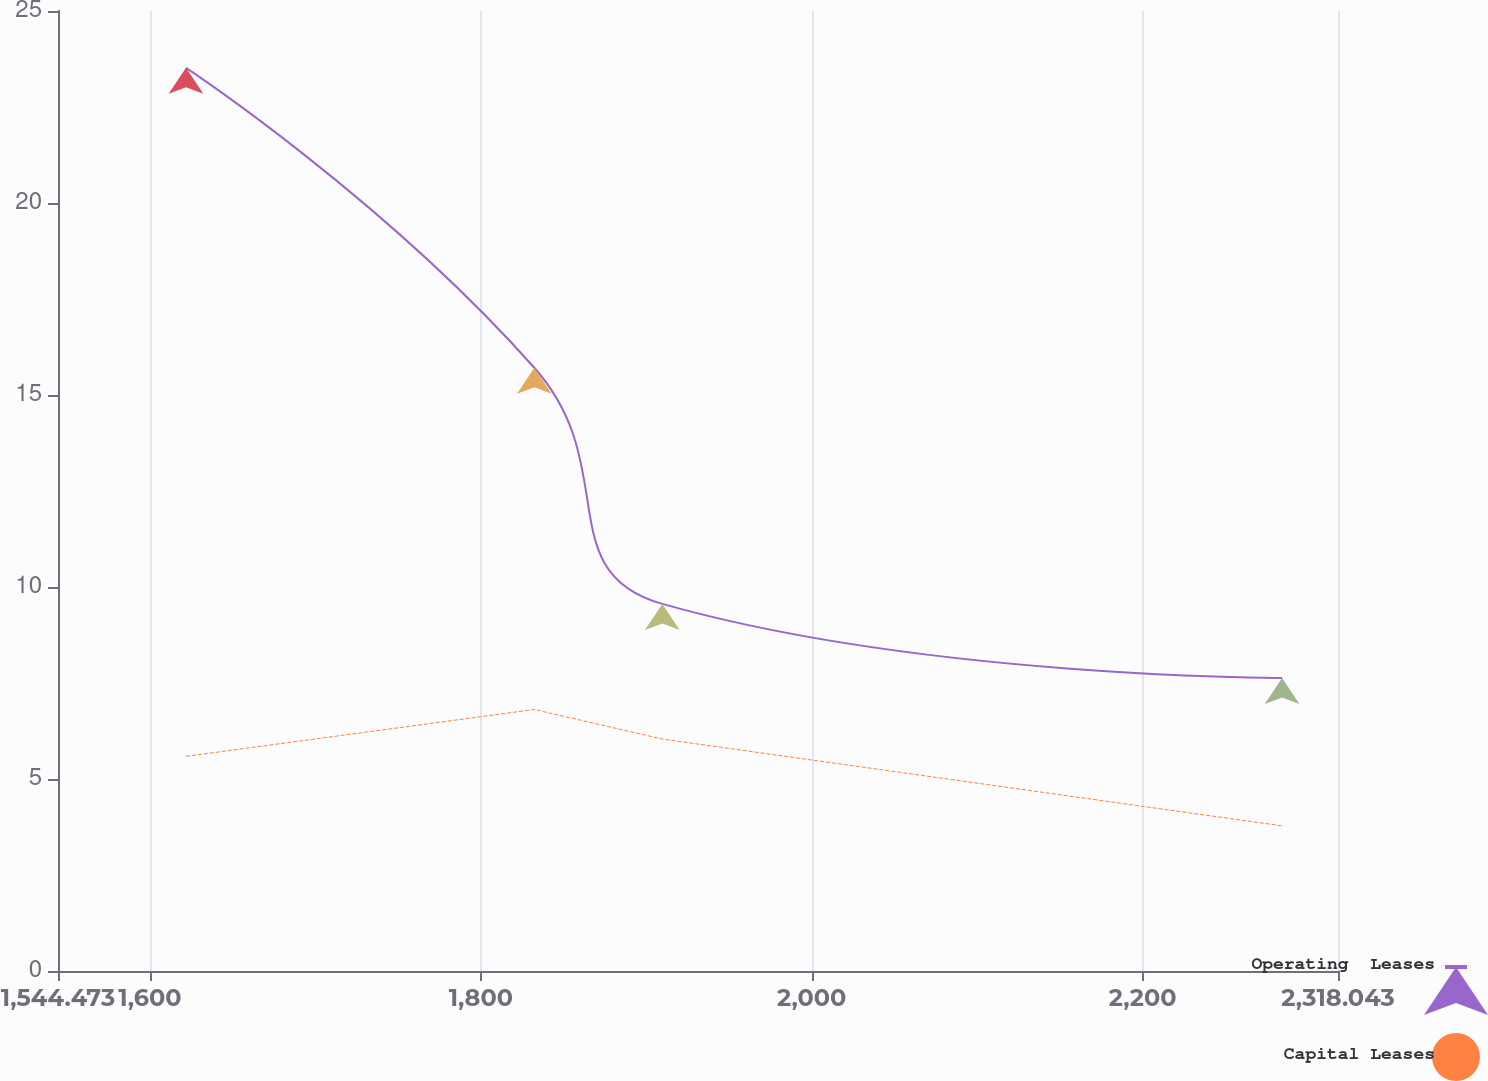<chart> <loc_0><loc_0><loc_500><loc_500><line_chart><ecel><fcel>Operating  Leases<fcel>Capital Leases<nl><fcel>1621.83<fcel>23.52<fcel>5.59<nl><fcel>1832.33<fcel>15.71<fcel>6.81<nl><fcel>1909.69<fcel>9.56<fcel>6.04<nl><fcel>2284.25<fcel>7.63<fcel>3.78<nl><fcel>2395.4<fcel>4.23<fcel>2.28<nl></chart> 